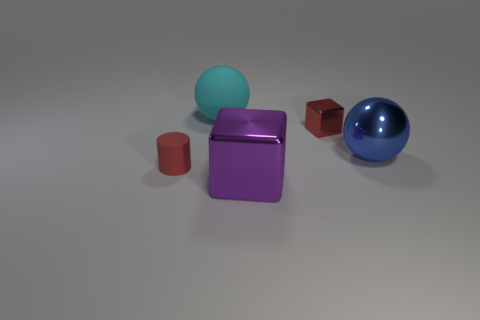Is the number of tiny blocks less than the number of tiny blue metallic spheres? Upon careful observation of the image, it is clear that the number of tiny blocks is indeed greater than the number of tiny blue metallic spheres. Specifically, there are two blocks and only one blue metallic sphere present in the visual. 